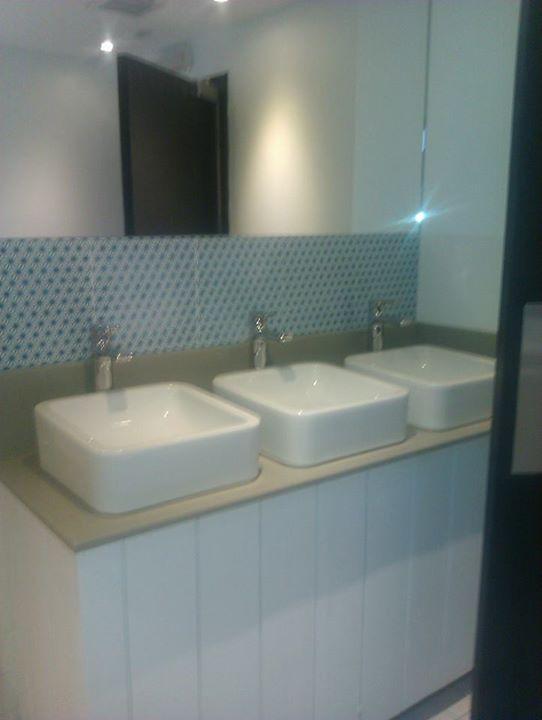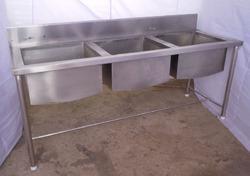The first image is the image on the left, the second image is the image on the right. Considering the images on both sides, is "There are exactly five faucets." valid? Answer yes or no. No. 